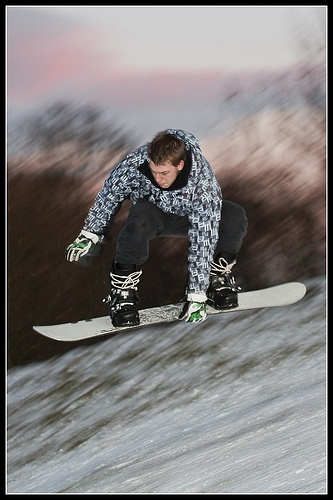Describe the objects in this image and their specific colors. I can see people in black, gray, darkgray, and lightgray tones and snowboard in black, darkgray, lightgray, and gray tones in this image. 